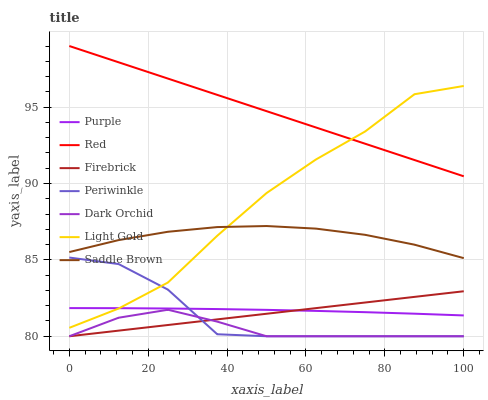Does Firebrick have the minimum area under the curve?
Answer yes or no. No. Does Firebrick have the maximum area under the curve?
Answer yes or no. No. Is Dark Orchid the smoothest?
Answer yes or no. No. Is Dark Orchid the roughest?
Answer yes or no. No. Does Light Gold have the lowest value?
Answer yes or no. No. Does Firebrick have the highest value?
Answer yes or no. No. Is Firebrick less than Saddle Brown?
Answer yes or no. Yes. Is Red greater than Dark Orchid?
Answer yes or no. Yes. Does Firebrick intersect Saddle Brown?
Answer yes or no. No. 